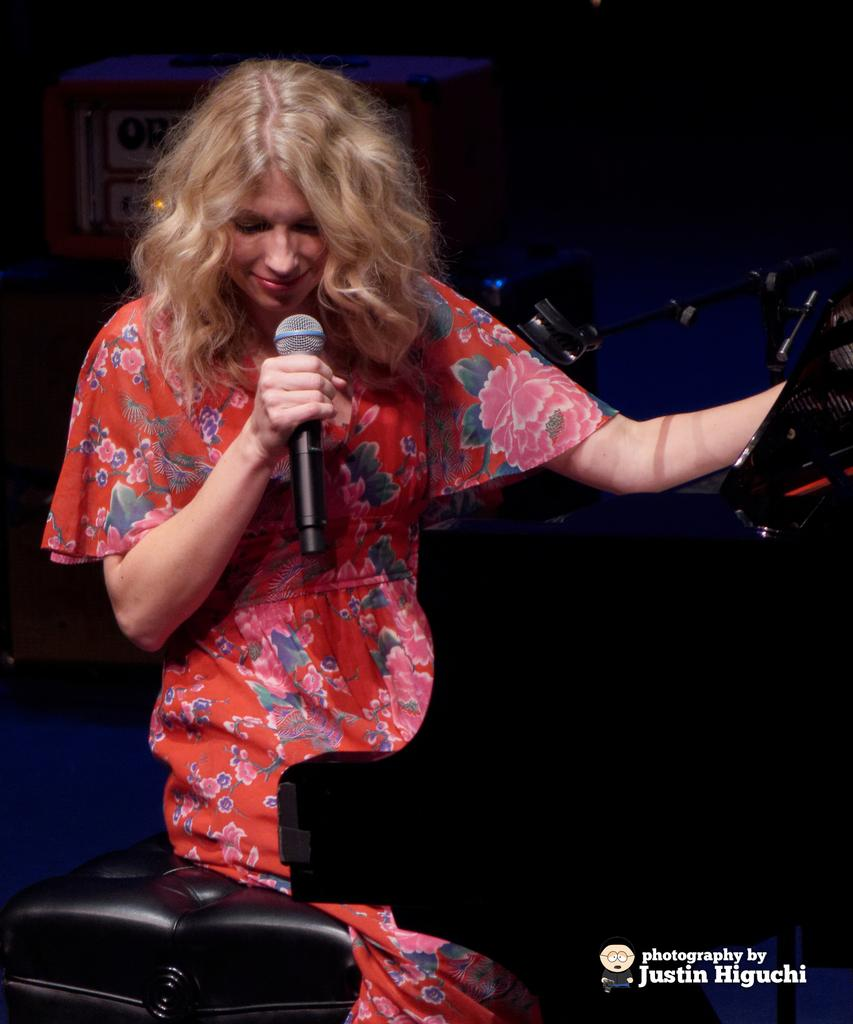Who is the main subject in the image? There is a woman in the image. What is the woman doing in the image? The woman is sitting. What is the woman wearing in the image? The woman is wearing a red dress. What object is the woman holding in the image? The woman is holding a microphone in her hand. How fast is the woman's aunt running in the image? There is no woman's aunt or running depicted in the image. 